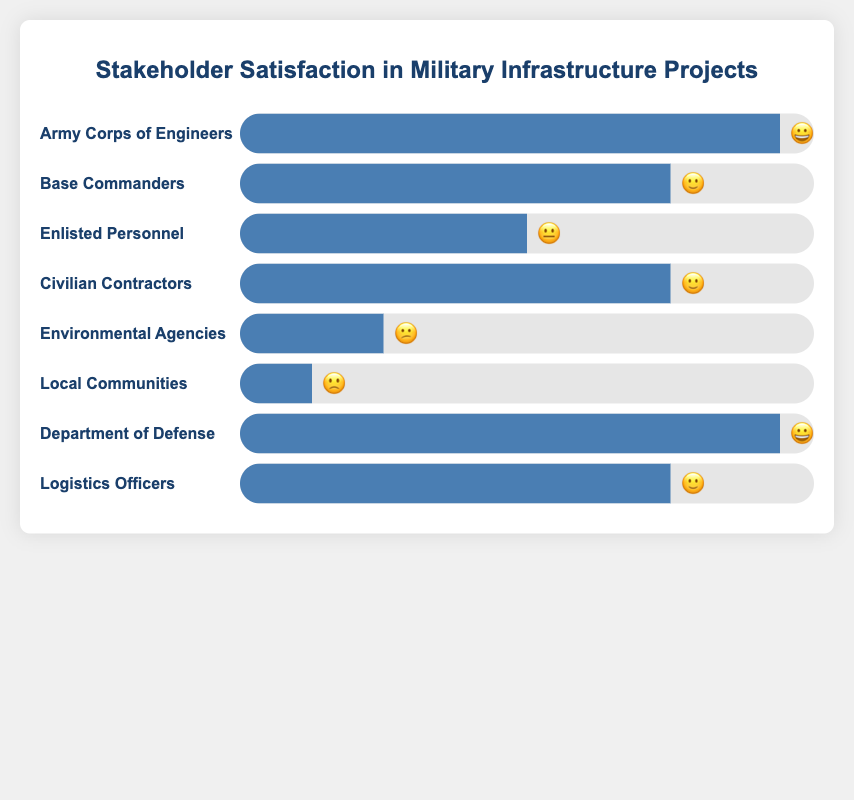What is the title of the chart? The title is found at the top of the chart, and it gives an idea of what the chart represents. Here, it is an overview of stakeholder satisfaction levels.
Answer: Stakeholder Satisfaction in Military Infrastructure Projects Which stakeholders have the highest satisfaction level? To identify the highest satisfaction level, look for the widest bars and the corresponding emojis. In this chart, the stakeholders with the widest bars and the "😀" emoji have the highest satisfaction.
Answer: Army Corps of Engineers, Department of Defense How many stakeholders are represented in the chart? Count the number of rows in the chart where each row represents a stakeholder group.
Answer: 8 Which stakeholder has the lowest satisfaction level? The lowest satisfaction level can be identified by the narrowest bar and the corresponding emoji. Here, the stakeholder with the "🙁" emoji has the lowest satisfaction.
Answer: Local Communities What fraction of stakeholders have a satisfaction level of "🙂"? Count the number of stakeholders with the "🙂" emoji and divide by the total number of stakeholders.
Answer: 3/8 How does the satisfaction level of Civilian Contractors compare to that of Enlisted Personnel? Compare the length of the satisfaction bars for Civilian Contractors and Enlisted Personnel. Civilian Contractors have a wider bar and a "🙂" emoji, while Enlisted Personnel have a narrower bar and a "😐" emoji.
Answer: Higher What is the satisfaction level of Environmental Agencies? Look at the corresponding emoji for Environmental Agencies in the chart.
Answer: 😕 Which stakeholders have a satisfaction level indicated by the "😐" emoji? Identify the stakeholder with the "😐" emoji by reviewing the chart's rows.
Answer: Enlisted Personnel If you were to average the satisfaction levels, where "😀" = 4, "🙂" = 3, "😐" = 2, "😕" = 1, and "🙁" = 0, what would be the average satisfaction score? Convert each emoji to the corresponding score and calculate the average.
(4 + 3 + 2 + 3 + 1 + 0 + 4 + 3) / 8 = 20 / 8 = 2.5
Answer: 2.5 Which stakeholders have the same satisfaction level? Identify stakeholders who share the same emoji and compare their satisfaction bars. Multiple stakeholders share the "🙂" emoji.
Answer: Base Commanders, Civilian Contractors, Logistics Officers 